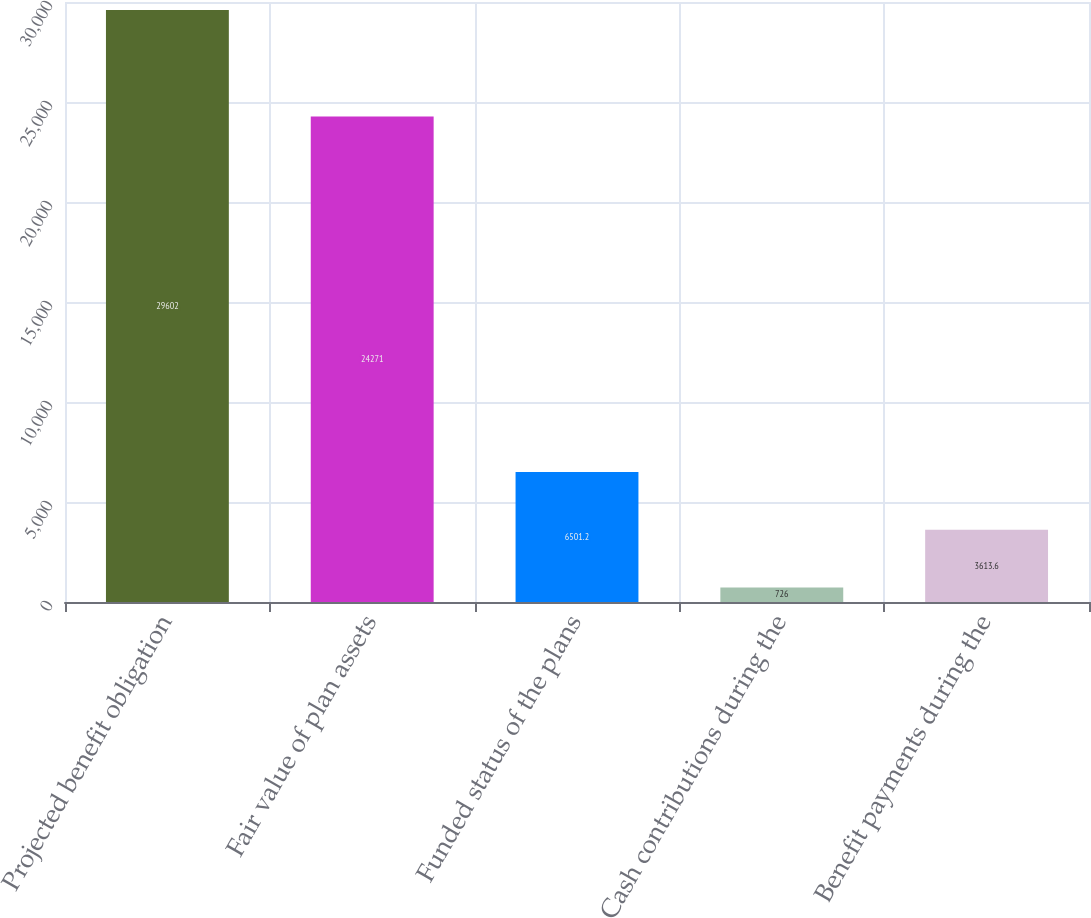Convert chart to OTSL. <chart><loc_0><loc_0><loc_500><loc_500><bar_chart><fcel>Projected benefit obligation<fcel>Fair value of plan assets<fcel>Funded status of the plans<fcel>Cash contributions during the<fcel>Benefit payments during the<nl><fcel>29602<fcel>24271<fcel>6501.2<fcel>726<fcel>3613.6<nl></chart> 